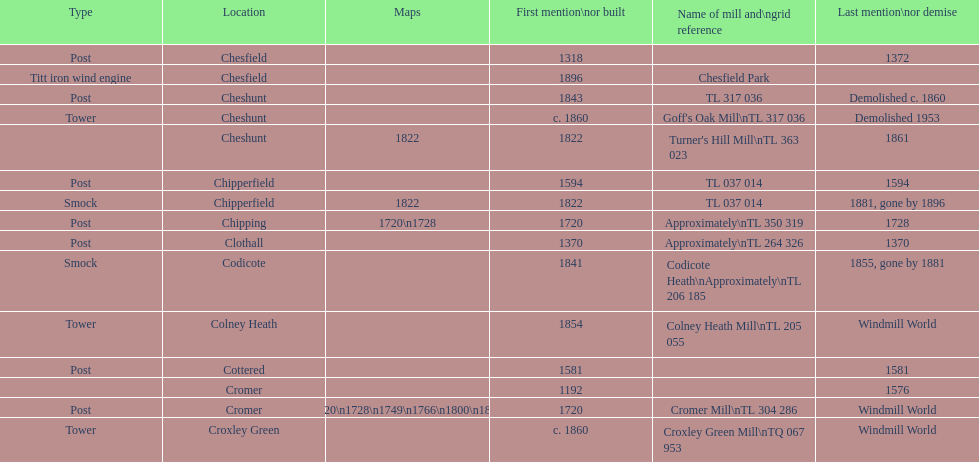How many mills were mentioned or built before 1700? 5. I'm looking to parse the entire table for insights. Could you assist me with that? {'header': ['Type', 'Location', 'Maps', 'First mention\\nor built', 'Name of mill and\\ngrid reference', 'Last mention\\nor demise'], 'rows': [['Post', 'Chesfield', '', '1318', '', '1372'], ['Titt iron wind engine', 'Chesfield', '', '1896', 'Chesfield Park', ''], ['Post', 'Cheshunt', '', '1843', 'TL 317 036', 'Demolished c. 1860'], ['Tower', 'Cheshunt', '', 'c. 1860', "Goff's Oak Mill\\nTL 317 036", 'Demolished 1953'], ['', 'Cheshunt', '1822', '1822', "Turner's Hill Mill\\nTL 363 023", '1861'], ['Post', 'Chipperfield', '', '1594', 'TL 037 014', '1594'], ['Smock', 'Chipperfield', '1822', '1822', 'TL 037 014', '1881, gone by 1896'], ['Post', 'Chipping', '1720\\n1728', '1720', 'Approximately\\nTL 350 319', '1728'], ['Post', 'Clothall', '', '1370', 'Approximately\\nTL 264 326', '1370'], ['Smock', 'Codicote', '', '1841', 'Codicote Heath\\nApproximately\\nTL 206 185', '1855, gone by 1881'], ['Tower', 'Colney Heath', '', '1854', 'Colney Heath Mill\\nTL 205 055', 'Windmill World'], ['Post', 'Cottered', '', '1581', '', '1581'], ['', 'Cromer', '', '1192', '', '1576'], ['Post', 'Cromer', '1720\\n1728\\n1749\\n1766\\n1800\\n1822', '1720', 'Cromer Mill\\nTL 304 286', 'Windmill World'], ['Tower', 'Croxley Green', '', 'c. 1860', 'Croxley Green Mill\\nTQ 067 953', 'Windmill World']]} 